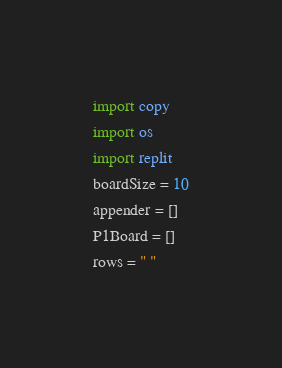<code> <loc_0><loc_0><loc_500><loc_500><_Python_>import copy
import os
import replit
boardSize = 10
appender = []
P1Board = []
rows = " "</code> 